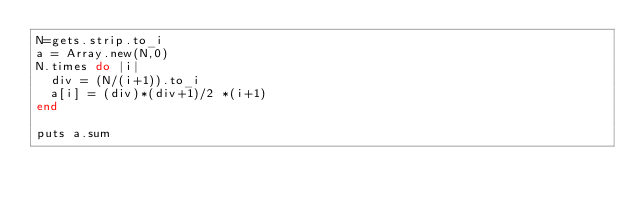Convert code to text. <code><loc_0><loc_0><loc_500><loc_500><_Ruby_>N=gets.strip.to_i
a = Array.new(N,0)
N.times do |i|
  div = (N/(i+1)).to_i
  a[i] = (div)*(div+1)/2 *(i+1)
end

puts a.sum</code> 